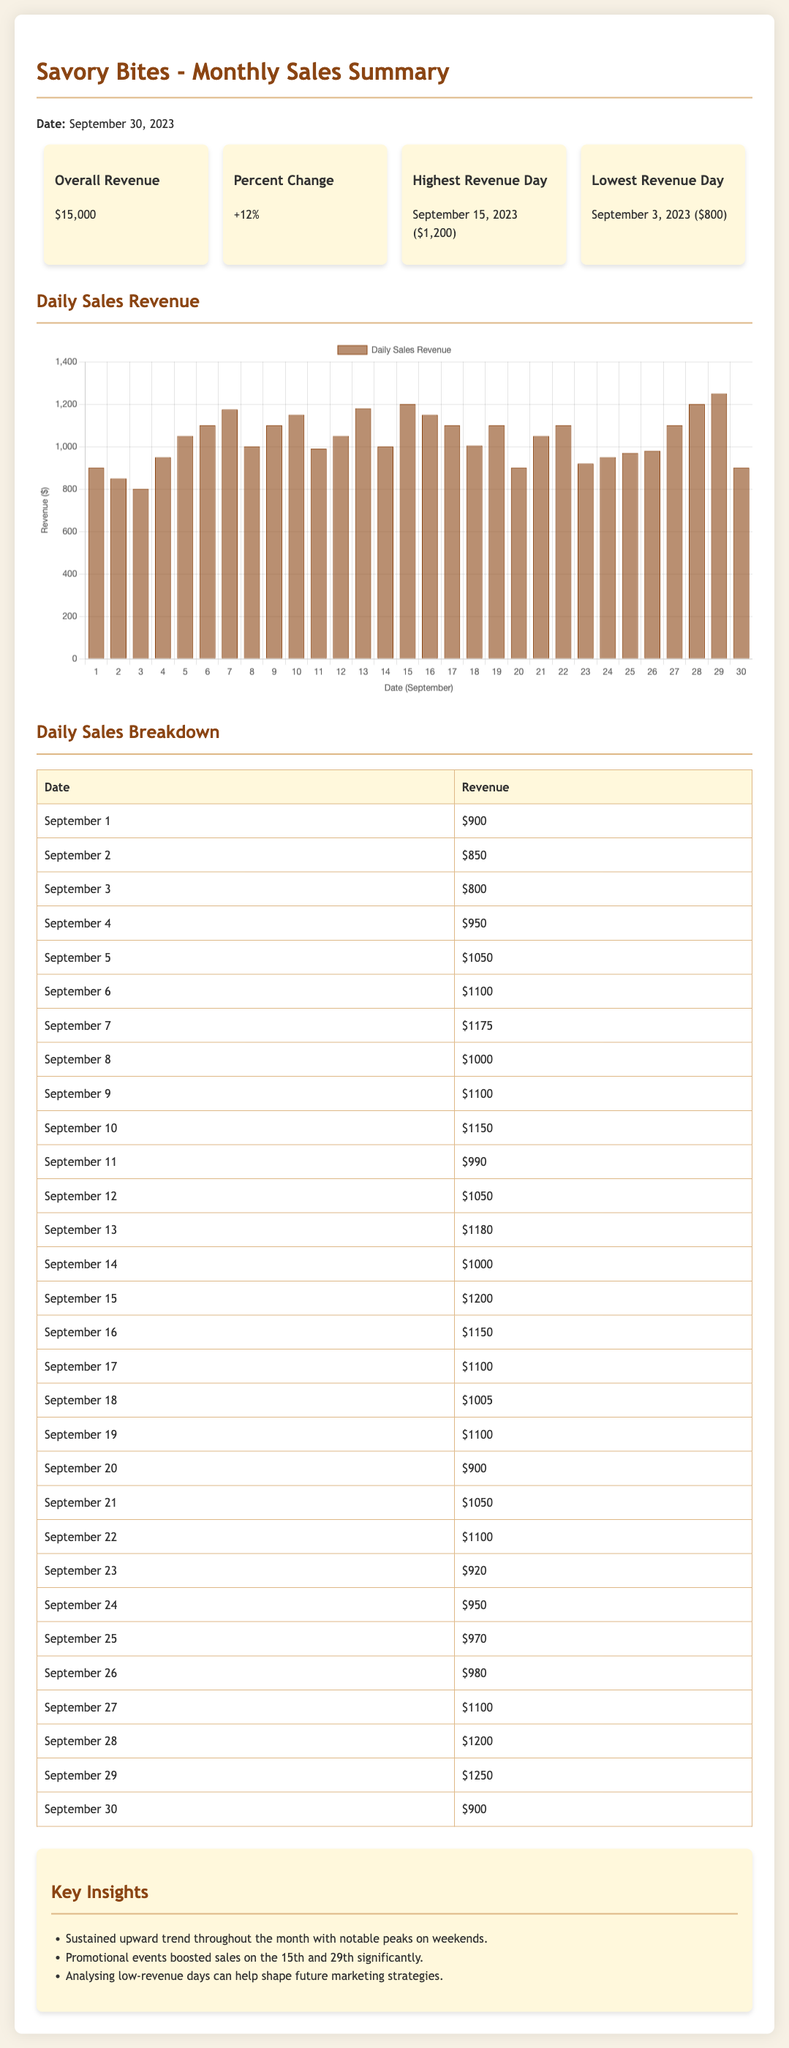What is the overall revenue for September 2023? The overall revenue is listed in the summary section of the document, which shows $15,000.
Answer: $15,000 What was the percent change in revenue from the previous month? The document mentions a percent change of +12% in the summary section.
Answer: +12% Which day had the highest revenue in September 2023? The highest revenue day is specified in the summary section as September 15, 2023, with a revenue of $1,200.
Answer: September 15, 2023 ($1,200) What was the lowest revenue day in September 2023? The document states the lowest revenue day was September 3, 2023, with a revenue of $800.
Answer: September 3, 2023 ($800) What trend is observed in the daily sales revenue throughout September? The key insights section summarizes that there was a sustained upward trend throughout the month.
Answer: Upward trend How many days had a revenue over $1,000 in September 2023? By reviewing the daily sales breakdown, we count the number of days listed with a revenue over $1,000. There are 12 days.
Answer: 12 days What dates had promotional events that boosted sales? The insights mention boosted sales due to promotional events specifically on the 15th and 29th of September.
Answer: 15th and 29th What style of chart is used to represent daily sales revenue? The document notes that a bar chart has been used to represent daily sales revenue in the graphical representation.
Answer: Bar chart 